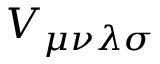<formula> <loc_0><loc_0><loc_500><loc_500>V _ { \mu \nu \lambda \sigma }</formula> 